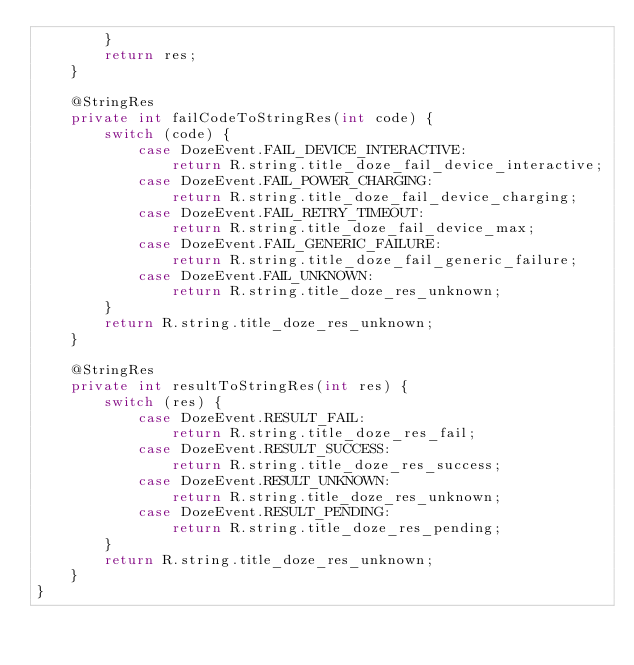Convert code to text. <code><loc_0><loc_0><loc_500><loc_500><_Java_>        }
        return res;
    }

    @StringRes
    private int failCodeToStringRes(int code) {
        switch (code) {
            case DozeEvent.FAIL_DEVICE_INTERACTIVE:
                return R.string.title_doze_fail_device_interactive;
            case DozeEvent.FAIL_POWER_CHARGING:
                return R.string.title_doze_fail_device_charging;
            case DozeEvent.FAIL_RETRY_TIMEOUT:
                return R.string.title_doze_fail_device_max;
            case DozeEvent.FAIL_GENERIC_FAILURE:
                return R.string.title_doze_fail_generic_failure;
            case DozeEvent.FAIL_UNKNOWN:
                return R.string.title_doze_res_unknown;
        }
        return R.string.title_doze_res_unknown;
    }

    @StringRes
    private int resultToStringRes(int res) {
        switch (res) {
            case DozeEvent.RESULT_FAIL:
                return R.string.title_doze_res_fail;
            case DozeEvent.RESULT_SUCCESS:
                return R.string.title_doze_res_success;
            case DozeEvent.RESULT_UNKNOWN:
                return R.string.title_doze_res_unknown;
            case DozeEvent.RESULT_PENDING:
                return R.string.title_doze_res_pending;
        }
        return R.string.title_doze_res_unknown;
    }
}
</code> 